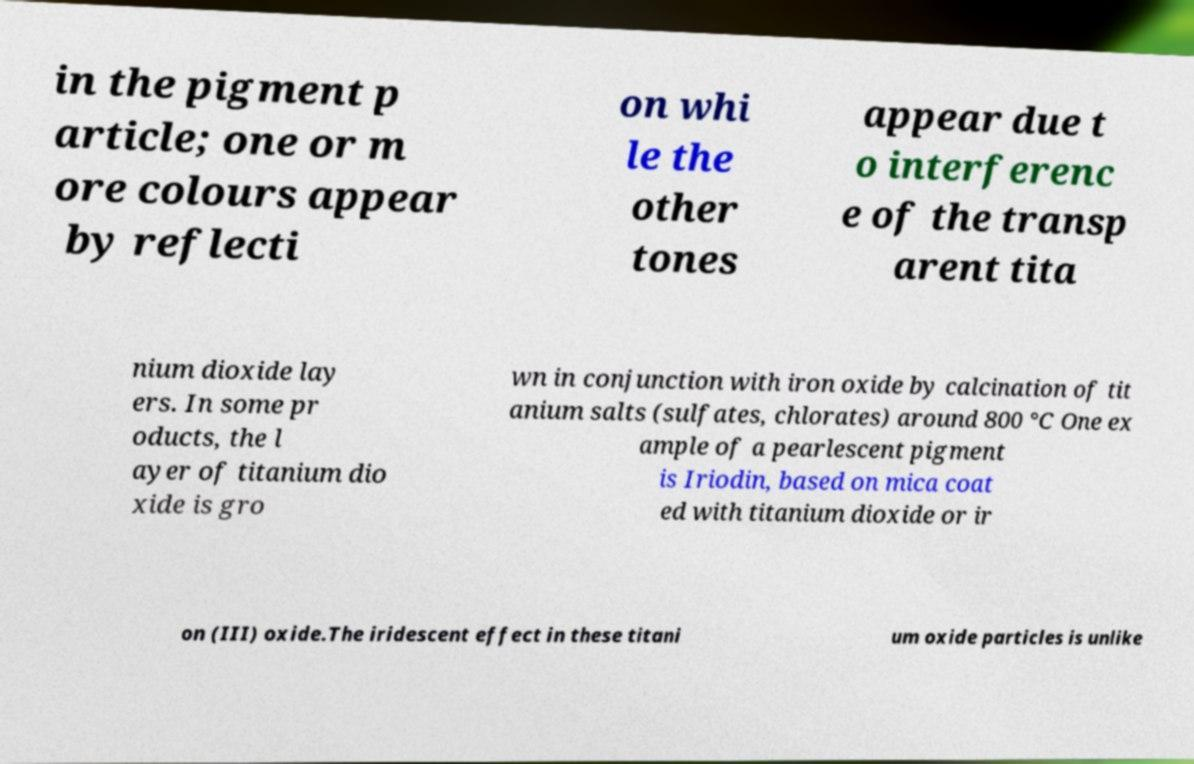For documentation purposes, I need the text within this image transcribed. Could you provide that? in the pigment p article; one or m ore colours appear by reflecti on whi le the other tones appear due t o interferenc e of the transp arent tita nium dioxide lay ers. In some pr oducts, the l ayer of titanium dio xide is gro wn in conjunction with iron oxide by calcination of tit anium salts (sulfates, chlorates) around 800 °C One ex ample of a pearlescent pigment is Iriodin, based on mica coat ed with titanium dioxide or ir on (III) oxide.The iridescent effect in these titani um oxide particles is unlike 